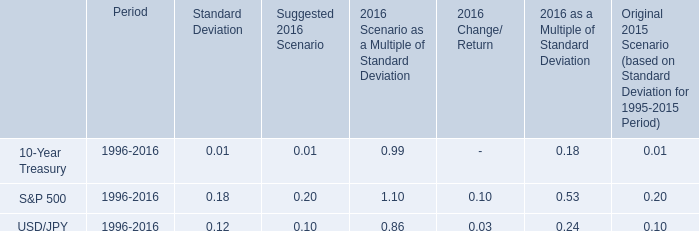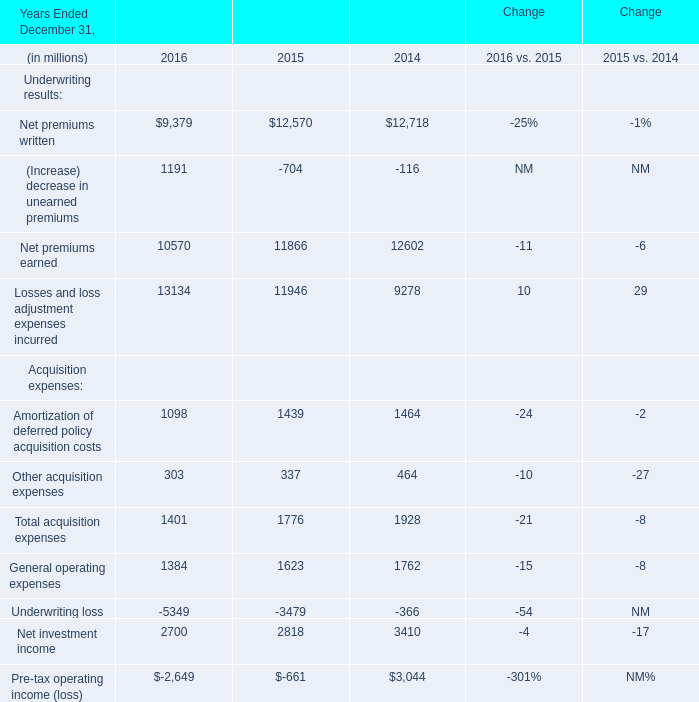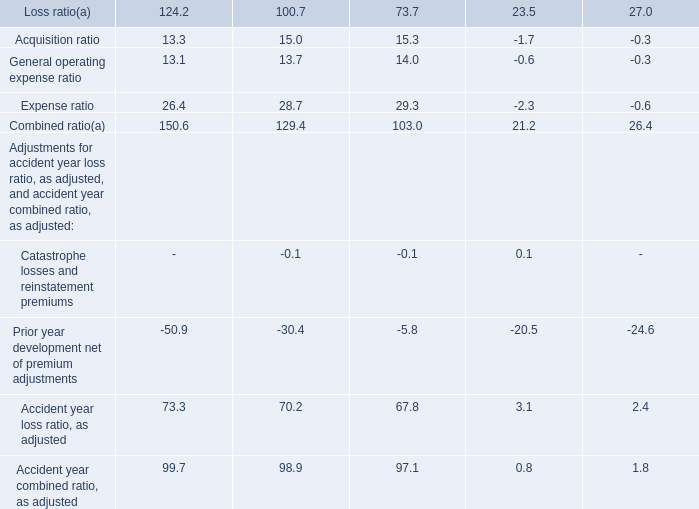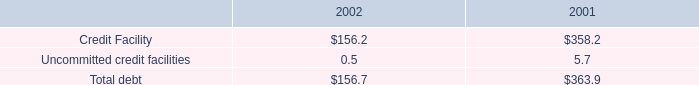What's the average of Net investment income in 2016, 2015, and 2014? (in million) 
Computations: (((2700 + 2818) + 3410) / 3)
Answer: 2976.0. 